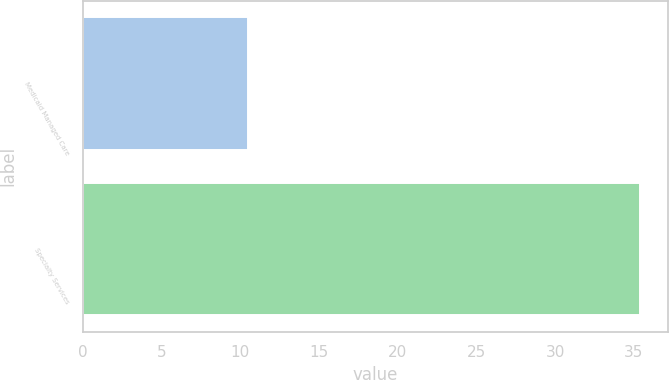<chart> <loc_0><loc_0><loc_500><loc_500><bar_chart><fcel>Medicaid Managed Care<fcel>Specialty Services<nl><fcel>10.5<fcel>35.4<nl></chart> 